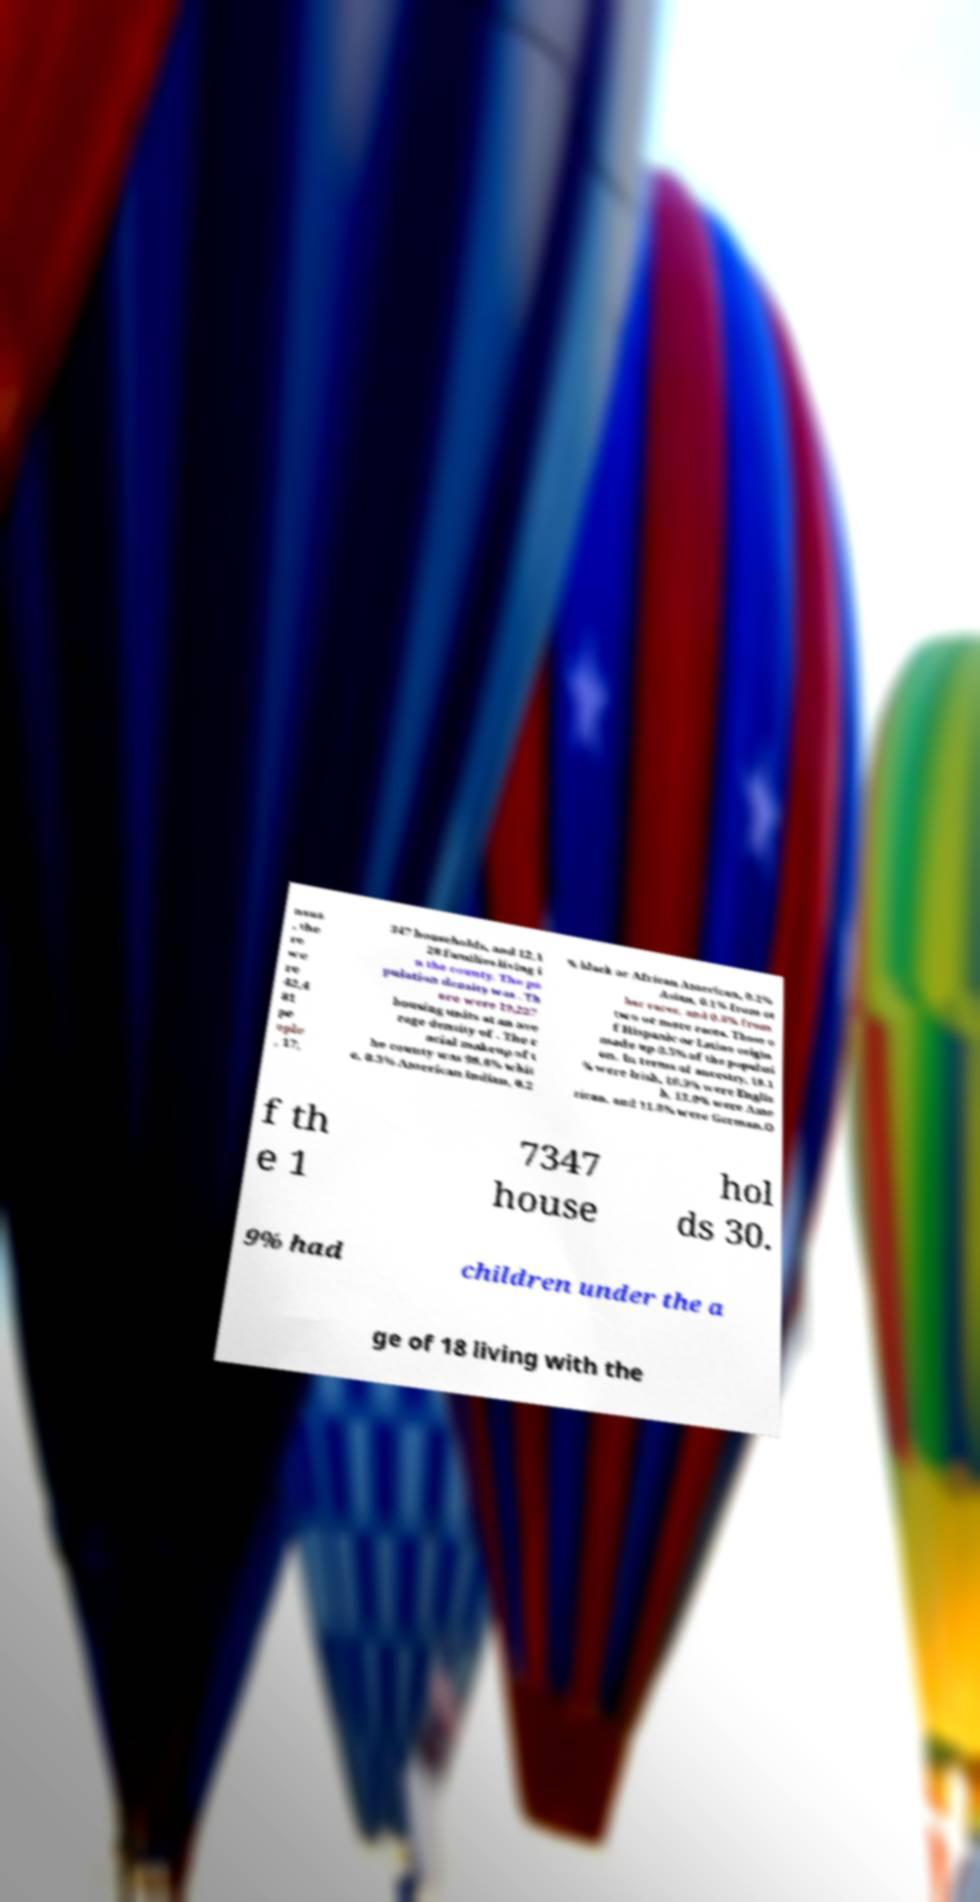What messages or text are displayed in this image? I need them in a readable, typed format. nsus , the re we re 42,4 81 pe ople , 17, 347 households, and 12,1 28 families living i n the county. The po pulation density was . Th ere were 19,227 housing units at an ave rage density of . The r acial makeup of t he county was 98.6% whit e, 0.3% American Indian, 0.2 % black or African American, 0.2% Asian, 0.1% from ot her races, and 0.8% from two or more races. Those o f Hispanic or Latino origin made up 0.5% of the populati on. In terms of ancestry, 18.1 % were Irish, 16.9% were Englis h, 13.0% were Ame rican, and 11.8% were German.O f th e 1 7347 house hol ds 30. 9% had children under the a ge of 18 living with the 